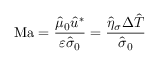<formula> <loc_0><loc_0><loc_500><loc_500>M a = \frac { \hat { \mu } _ { 0 } \hat { u } ^ { * } } { \varepsilon \hat { \sigma } _ { 0 } } = \frac { \hat { \eta } _ { \sigma } \Delta \hat { T } } { \hat { \sigma } _ { 0 } }</formula> 